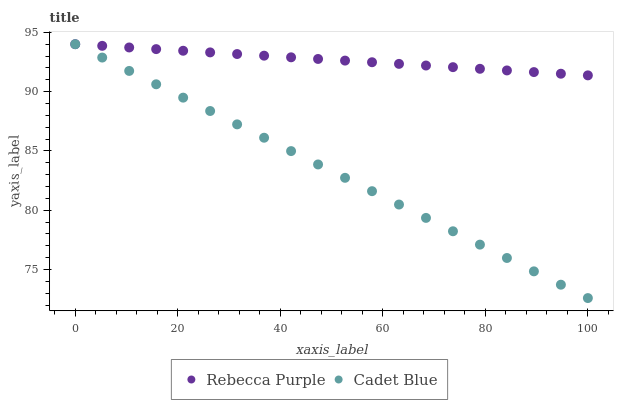Does Cadet Blue have the minimum area under the curve?
Answer yes or no. Yes. Does Rebecca Purple have the maximum area under the curve?
Answer yes or no. Yes. Does Rebecca Purple have the minimum area under the curve?
Answer yes or no. No. Is Rebecca Purple the smoothest?
Answer yes or no. Yes. Is Cadet Blue the roughest?
Answer yes or no. Yes. Is Rebecca Purple the roughest?
Answer yes or no. No. Does Cadet Blue have the lowest value?
Answer yes or no. Yes. Does Rebecca Purple have the lowest value?
Answer yes or no. No. Does Rebecca Purple have the highest value?
Answer yes or no. Yes. Does Cadet Blue intersect Rebecca Purple?
Answer yes or no. Yes. Is Cadet Blue less than Rebecca Purple?
Answer yes or no. No. Is Cadet Blue greater than Rebecca Purple?
Answer yes or no. No. 